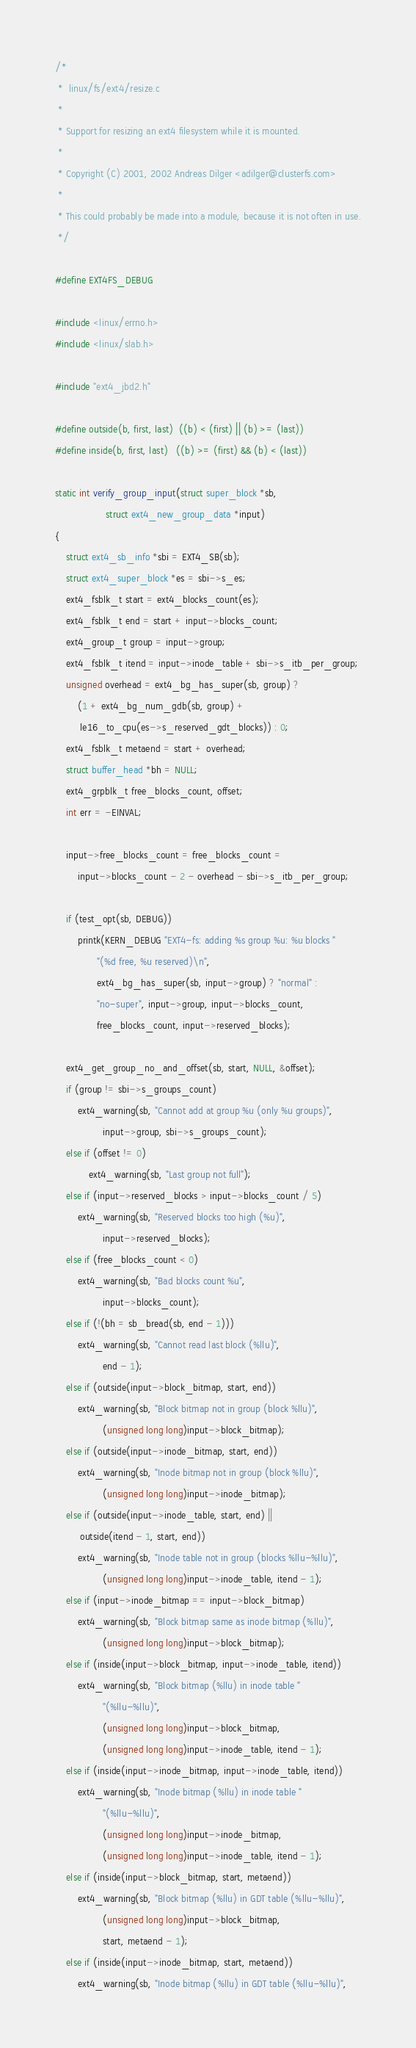Convert code to text. <code><loc_0><loc_0><loc_500><loc_500><_C_>/*
 *  linux/fs/ext4/resize.c
 *
 * Support for resizing an ext4 filesystem while it is mounted.
 *
 * Copyright (C) 2001, 2002 Andreas Dilger <adilger@clusterfs.com>
 *
 * This could probably be made into a module, because it is not often in use.
 */

#define EXT4FS_DEBUG

#include <linux/errno.h>
#include <linux/slab.h>

#include "ext4_jbd2.h"

#define outside(b, first, last)	((b) < (first) || (b) >= (last))
#define inside(b, first, last)	((b) >= (first) && (b) < (last))

static int verify_group_input(struct super_block *sb,
			      struct ext4_new_group_data *input)
{
	struct ext4_sb_info *sbi = EXT4_SB(sb);
	struct ext4_super_block *es = sbi->s_es;
	ext4_fsblk_t start = ext4_blocks_count(es);
	ext4_fsblk_t end = start + input->blocks_count;
	ext4_group_t group = input->group;
	ext4_fsblk_t itend = input->inode_table + sbi->s_itb_per_group;
	unsigned overhead = ext4_bg_has_super(sb, group) ?
		(1 + ext4_bg_num_gdb(sb, group) +
		 le16_to_cpu(es->s_reserved_gdt_blocks)) : 0;
	ext4_fsblk_t metaend = start + overhead;
	struct buffer_head *bh = NULL;
	ext4_grpblk_t free_blocks_count, offset;
	int err = -EINVAL;

	input->free_blocks_count = free_blocks_count =
		input->blocks_count - 2 - overhead - sbi->s_itb_per_group;

	if (test_opt(sb, DEBUG))
		printk(KERN_DEBUG "EXT4-fs: adding %s group %u: %u blocks "
		       "(%d free, %u reserved)\n",
		       ext4_bg_has_super(sb, input->group) ? "normal" :
		       "no-super", input->group, input->blocks_count,
		       free_blocks_count, input->reserved_blocks);

	ext4_get_group_no_and_offset(sb, start, NULL, &offset);
	if (group != sbi->s_groups_count)
		ext4_warning(sb, "Cannot add at group %u (only %u groups)",
			     input->group, sbi->s_groups_count);
	else if (offset != 0)
			ext4_warning(sb, "Last group not full");
	else if (input->reserved_blocks > input->blocks_count / 5)
		ext4_warning(sb, "Reserved blocks too high (%u)",
			     input->reserved_blocks);
	else if (free_blocks_count < 0)
		ext4_warning(sb, "Bad blocks count %u",
			     input->blocks_count);
	else if (!(bh = sb_bread(sb, end - 1)))
		ext4_warning(sb, "Cannot read last block (%llu)",
			     end - 1);
	else if (outside(input->block_bitmap, start, end))
		ext4_warning(sb, "Block bitmap not in group (block %llu)",
			     (unsigned long long)input->block_bitmap);
	else if (outside(input->inode_bitmap, start, end))
		ext4_warning(sb, "Inode bitmap not in group (block %llu)",
			     (unsigned long long)input->inode_bitmap);
	else if (outside(input->inode_table, start, end) ||
		 outside(itend - 1, start, end))
		ext4_warning(sb, "Inode table not in group (blocks %llu-%llu)",
			     (unsigned long long)input->inode_table, itend - 1);
	else if (input->inode_bitmap == input->block_bitmap)
		ext4_warning(sb, "Block bitmap same as inode bitmap (%llu)",
			     (unsigned long long)input->block_bitmap);
	else if (inside(input->block_bitmap, input->inode_table, itend))
		ext4_warning(sb, "Block bitmap (%llu) in inode table "
			     "(%llu-%llu)",
			     (unsigned long long)input->block_bitmap,
			     (unsigned long long)input->inode_table, itend - 1);
	else if (inside(input->inode_bitmap, input->inode_table, itend))
		ext4_warning(sb, "Inode bitmap (%llu) in inode table "
			     "(%llu-%llu)",
			     (unsigned long long)input->inode_bitmap,
			     (unsigned long long)input->inode_table, itend - 1);
	else if (inside(input->block_bitmap, start, metaend))
		ext4_warning(sb, "Block bitmap (%llu) in GDT table (%llu-%llu)",
			     (unsigned long long)input->block_bitmap,
			     start, metaend - 1);
	else if (inside(input->inode_bitmap, start, metaend))
		ext4_warning(sb, "Inode bitmap (%llu) in GDT table (%llu-%llu)",</code> 